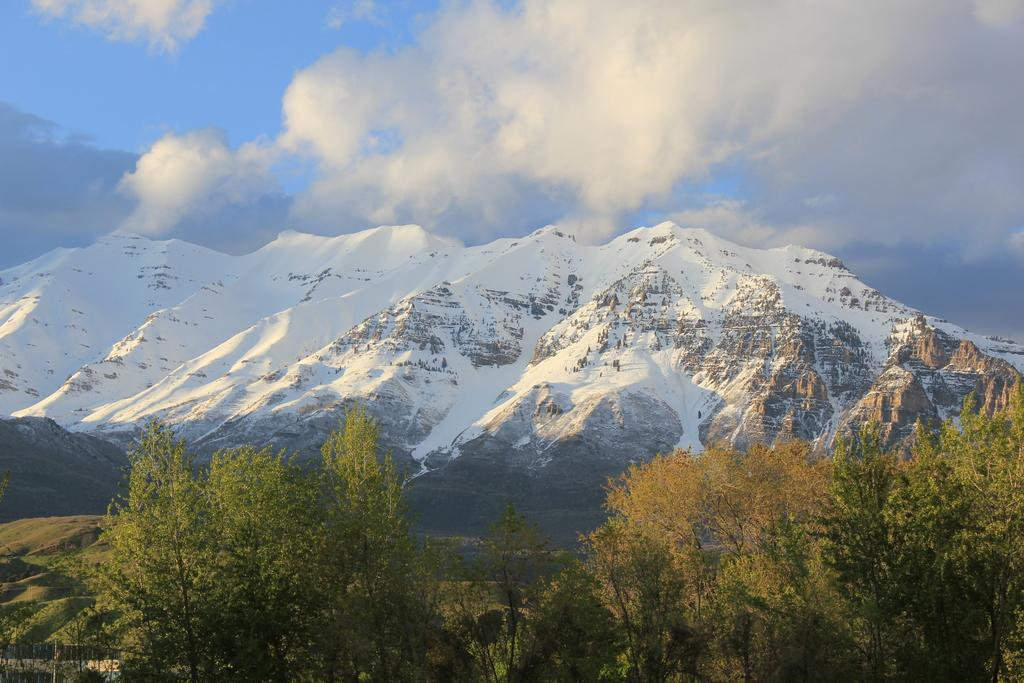What type of vegetation can be seen in the image? There are trees in the image. What is the color of the trees in the image? The trees are green in color. What can be seen in the background of the image? There are mountains visible in the background of the image. What is visible in the sky in the image? The sky has a combination of white and blue colors. What type of cap can be seen on the trees in the image? There are no caps present on the trees in the image; they are just green trees. What is the texture of the balloon visible in the image? There is no balloon present in the image. 